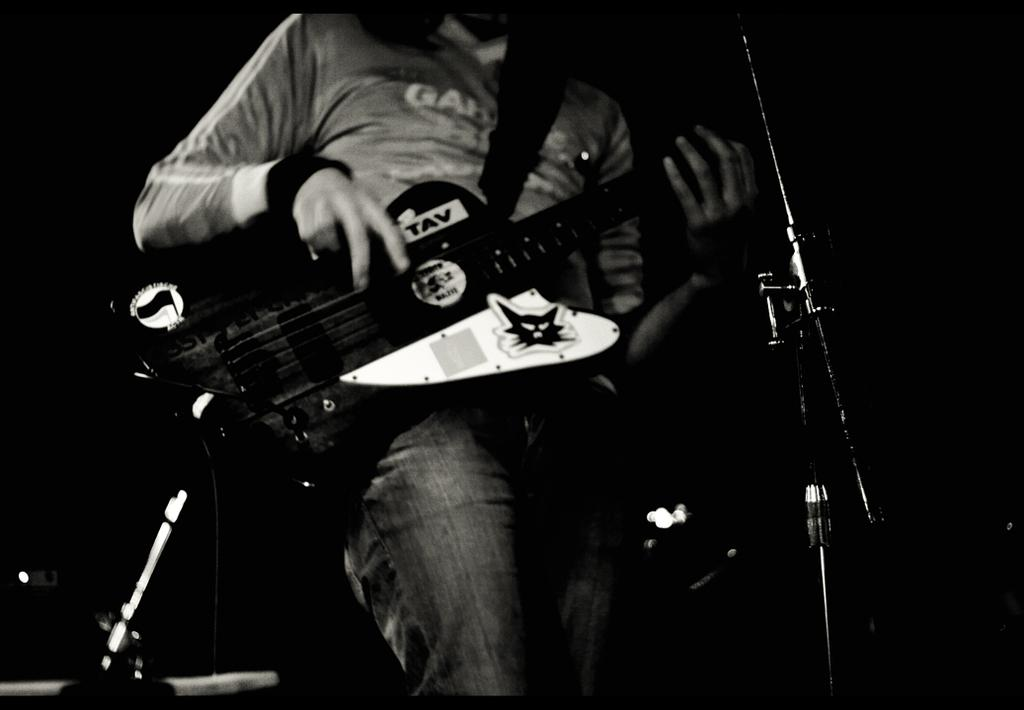What is the person in the image doing? The person is playing a guitar. What object is present in the image that is commonly used for amplifying sound? A: There is a microphone with a stand in the image. How does the person in the image breathe while playing the guitar? The image does not show the person breathing, and it is not possible to determine their breathing pattern from the image alone. 